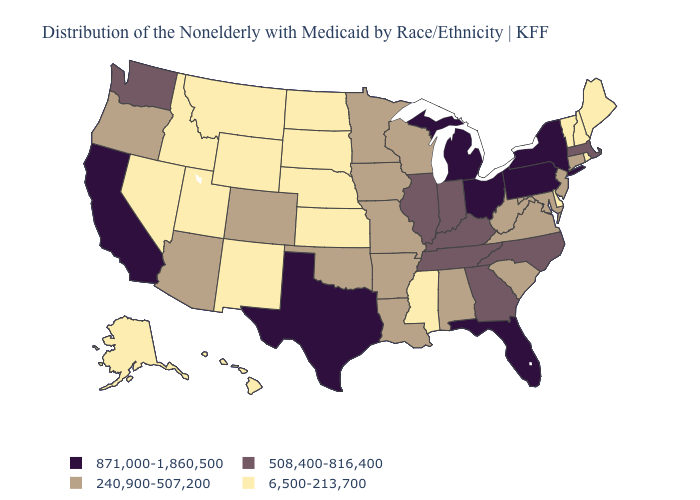Among the states that border Wyoming , which have the lowest value?
Give a very brief answer. Idaho, Montana, Nebraska, South Dakota, Utah. Does California have the highest value in the West?
Short answer required. Yes. Does Indiana have the highest value in the MidWest?
Quick response, please. No. Does Utah have the lowest value in the West?
Write a very short answer. Yes. How many symbols are there in the legend?
Answer briefly. 4. Does New Mexico have the highest value in the USA?
Be succinct. No. Among the states that border Arkansas , which have the lowest value?
Concise answer only. Mississippi. Which states have the highest value in the USA?
Write a very short answer. California, Florida, Michigan, New York, Ohio, Pennsylvania, Texas. What is the value of New Jersey?
Short answer required. 240,900-507,200. What is the lowest value in the USA?
Quick response, please. 6,500-213,700. What is the lowest value in states that border Delaware?
Keep it brief. 240,900-507,200. Name the states that have a value in the range 508,400-816,400?
Keep it brief. Georgia, Illinois, Indiana, Kentucky, Massachusetts, North Carolina, Tennessee, Washington. What is the highest value in the MidWest ?
Write a very short answer. 871,000-1,860,500. What is the value of Massachusetts?
Be succinct. 508,400-816,400. Among the states that border Maine , which have the highest value?
Short answer required. New Hampshire. 